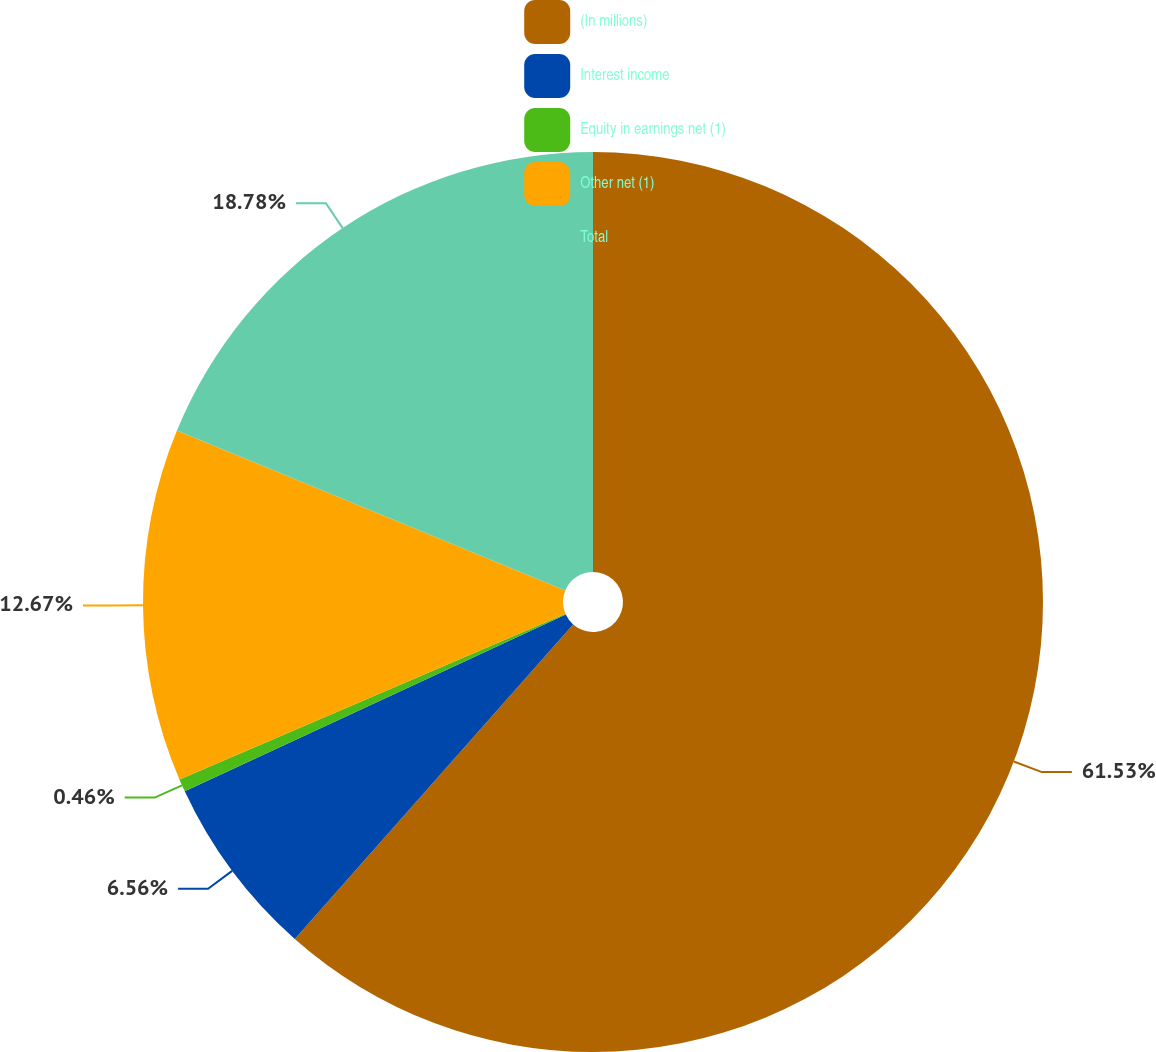Convert chart to OTSL. <chart><loc_0><loc_0><loc_500><loc_500><pie_chart><fcel>(In millions)<fcel>Interest income<fcel>Equity in earnings net (1)<fcel>Other net (1)<fcel>Total<nl><fcel>61.53%<fcel>6.56%<fcel>0.46%<fcel>12.67%<fcel>18.78%<nl></chart> 